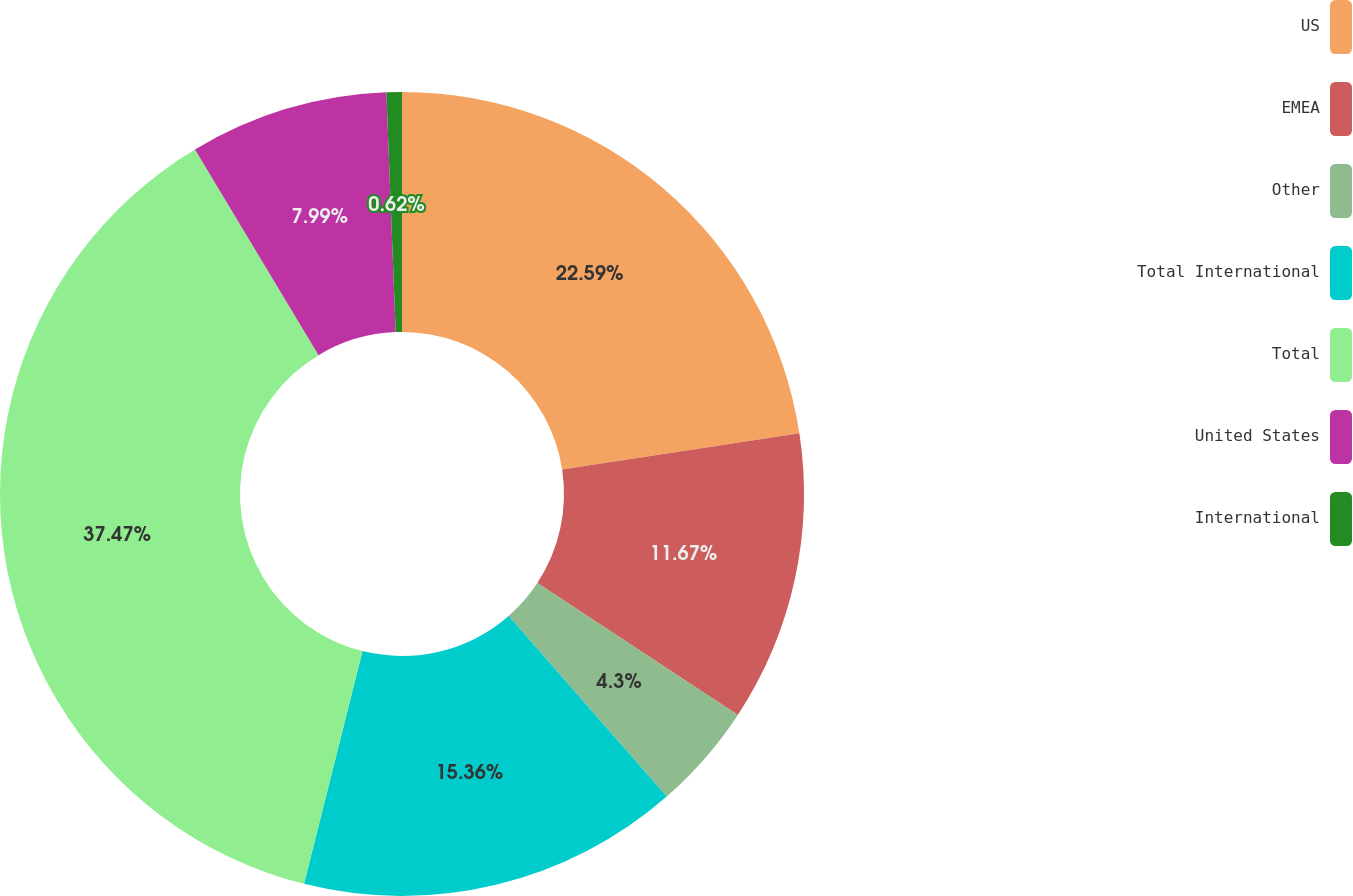Convert chart to OTSL. <chart><loc_0><loc_0><loc_500><loc_500><pie_chart><fcel>US<fcel>EMEA<fcel>Other<fcel>Total International<fcel>Total<fcel>United States<fcel>International<nl><fcel>22.59%<fcel>11.67%<fcel>4.3%<fcel>15.36%<fcel>37.47%<fcel>7.99%<fcel>0.62%<nl></chart> 